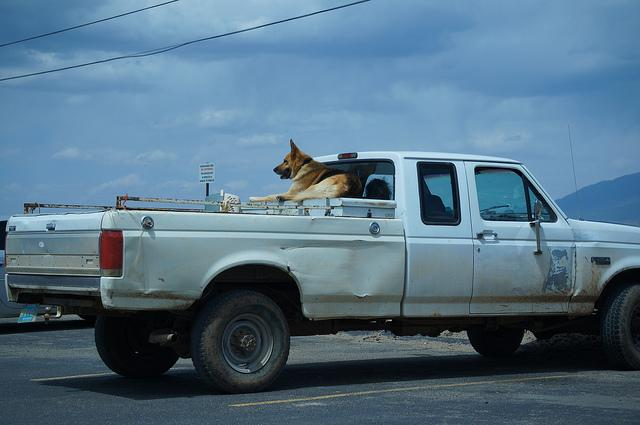Which truck does this dog's owner possess?

Choices:
A) blue truck
B) semi truck
C) distant truck
D) white truck white truck 